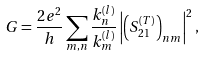Convert formula to latex. <formula><loc_0><loc_0><loc_500><loc_500>G = \frac { 2 e ^ { 2 } } { h } \sum _ { m , n } \frac { k ^ { ( l ) } _ { n } } { k ^ { ( l ) } _ { m } } \left | \left ( S ^ { ( T ) } _ { 2 1 } \right ) _ { n m } \right | ^ { 2 } ,</formula> 